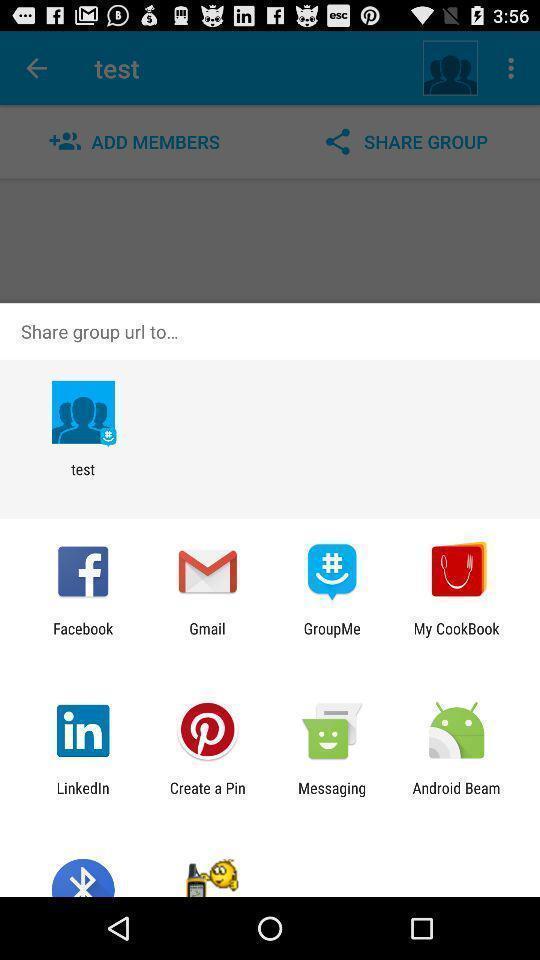Give me a summary of this screen capture. Popup showing different apps to share. 